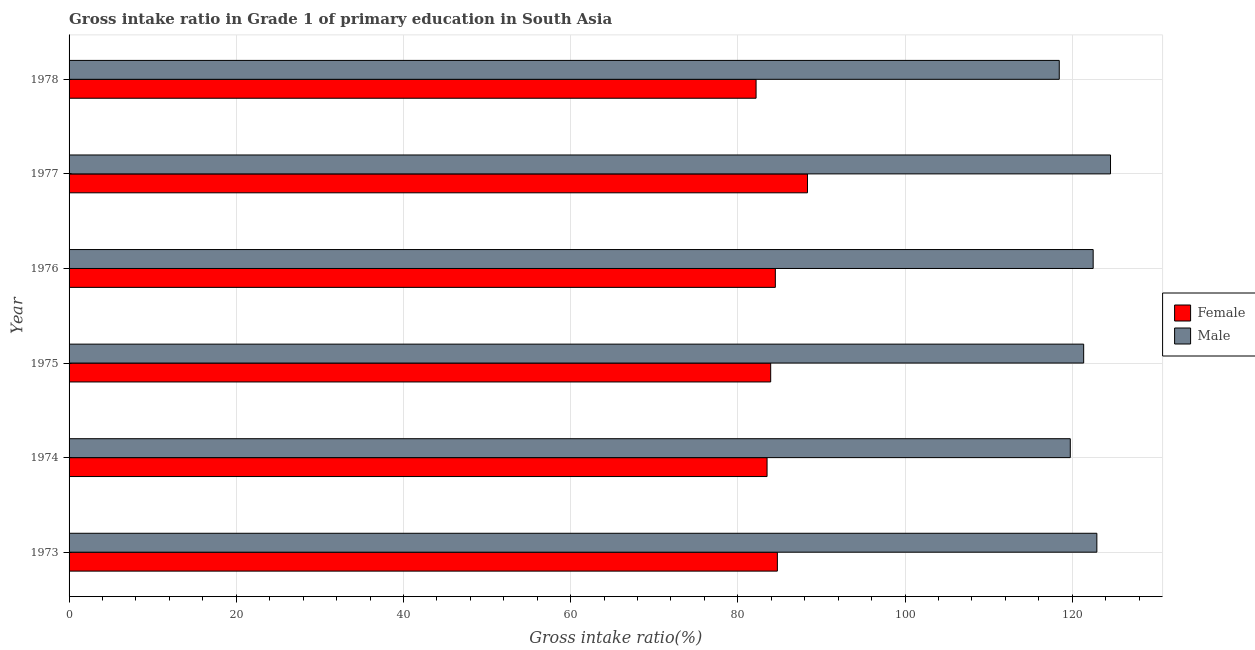How many different coloured bars are there?
Make the answer very short. 2. Are the number of bars on each tick of the Y-axis equal?
Offer a terse response. Yes. How many bars are there on the 2nd tick from the bottom?
Offer a very short reply. 2. What is the label of the 4th group of bars from the top?
Offer a very short reply. 1975. What is the gross intake ratio(female) in 1974?
Make the answer very short. 83.5. Across all years, what is the maximum gross intake ratio(male)?
Your answer should be very brief. 124.58. Across all years, what is the minimum gross intake ratio(male)?
Ensure brevity in your answer.  118.45. In which year was the gross intake ratio(male) minimum?
Ensure brevity in your answer.  1978. What is the total gross intake ratio(male) in the graph?
Keep it short and to the point. 729.63. What is the difference between the gross intake ratio(female) in 1973 and that in 1974?
Your response must be concise. 1.23. What is the difference between the gross intake ratio(female) in 1976 and the gross intake ratio(male) in 1974?
Keep it short and to the point. -35.28. What is the average gross intake ratio(male) per year?
Your answer should be compact. 121.6. In the year 1975, what is the difference between the gross intake ratio(male) and gross intake ratio(female)?
Provide a succinct answer. 37.44. What is the ratio of the gross intake ratio(female) in 1974 to that in 1977?
Your answer should be compact. 0.94. What is the difference between the highest and the second highest gross intake ratio(male)?
Make the answer very short. 1.63. What is the difference between the highest and the lowest gross intake ratio(female)?
Your answer should be compact. 6.15. In how many years, is the gross intake ratio(female) greater than the average gross intake ratio(female) taken over all years?
Give a very brief answer. 2. Is the sum of the gross intake ratio(female) in 1973 and 1977 greater than the maximum gross intake ratio(male) across all years?
Your response must be concise. Yes. How many bars are there?
Provide a succinct answer. 12. What is the difference between two consecutive major ticks on the X-axis?
Make the answer very short. 20. Are the values on the major ticks of X-axis written in scientific E-notation?
Your answer should be compact. No. Does the graph contain grids?
Offer a terse response. Yes. What is the title of the graph?
Provide a succinct answer. Gross intake ratio in Grade 1 of primary education in South Asia. Does "Revenue" appear as one of the legend labels in the graph?
Offer a terse response. No. What is the label or title of the X-axis?
Your response must be concise. Gross intake ratio(%). What is the label or title of the Y-axis?
Give a very brief answer. Year. What is the Gross intake ratio(%) of Female in 1973?
Your response must be concise. 84.73. What is the Gross intake ratio(%) in Male in 1973?
Give a very brief answer. 122.95. What is the Gross intake ratio(%) in Female in 1974?
Keep it short and to the point. 83.5. What is the Gross intake ratio(%) of Male in 1974?
Your answer should be compact. 119.77. What is the Gross intake ratio(%) in Female in 1975?
Make the answer very short. 83.93. What is the Gross intake ratio(%) in Male in 1975?
Give a very brief answer. 121.37. What is the Gross intake ratio(%) in Female in 1976?
Your response must be concise. 84.49. What is the Gross intake ratio(%) of Male in 1976?
Give a very brief answer. 122.51. What is the Gross intake ratio(%) of Female in 1977?
Keep it short and to the point. 88.33. What is the Gross intake ratio(%) in Male in 1977?
Offer a terse response. 124.58. What is the Gross intake ratio(%) in Female in 1978?
Offer a terse response. 82.18. What is the Gross intake ratio(%) of Male in 1978?
Make the answer very short. 118.45. Across all years, what is the maximum Gross intake ratio(%) of Female?
Make the answer very short. 88.33. Across all years, what is the maximum Gross intake ratio(%) in Male?
Keep it short and to the point. 124.58. Across all years, what is the minimum Gross intake ratio(%) in Female?
Provide a succinct answer. 82.18. Across all years, what is the minimum Gross intake ratio(%) of Male?
Your answer should be very brief. 118.45. What is the total Gross intake ratio(%) in Female in the graph?
Your answer should be compact. 507.16. What is the total Gross intake ratio(%) of Male in the graph?
Provide a short and direct response. 729.63. What is the difference between the Gross intake ratio(%) in Female in 1973 and that in 1974?
Give a very brief answer. 1.23. What is the difference between the Gross intake ratio(%) of Male in 1973 and that in 1974?
Offer a very short reply. 3.18. What is the difference between the Gross intake ratio(%) in Female in 1973 and that in 1975?
Provide a succinct answer. 0.8. What is the difference between the Gross intake ratio(%) of Male in 1973 and that in 1975?
Offer a terse response. 1.58. What is the difference between the Gross intake ratio(%) in Female in 1973 and that in 1976?
Offer a terse response. 0.24. What is the difference between the Gross intake ratio(%) in Male in 1973 and that in 1976?
Your answer should be very brief. 0.44. What is the difference between the Gross intake ratio(%) in Female in 1973 and that in 1977?
Offer a terse response. -3.6. What is the difference between the Gross intake ratio(%) in Male in 1973 and that in 1977?
Offer a terse response. -1.63. What is the difference between the Gross intake ratio(%) of Female in 1973 and that in 1978?
Your answer should be very brief. 2.55. What is the difference between the Gross intake ratio(%) in Male in 1973 and that in 1978?
Ensure brevity in your answer.  4.5. What is the difference between the Gross intake ratio(%) of Female in 1974 and that in 1975?
Keep it short and to the point. -0.43. What is the difference between the Gross intake ratio(%) of Male in 1974 and that in 1975?
Your answer should be very brief. -1.6. What is the difference between the Gross intake ratio(%) of Female in 1974 and that in 1976?
Ensure brevity in your answer.  -0.99. What is the difference between the Gross intake ratio(%) of Male in 1974 and that in 1976?
Offer a very short reply. -2.73. What is the difference between the Gross intake ratio(%) of Female in 1974 and that in 1977?
Provide a succinct answer. -4.84. What is the difference between the Gross intake ratio(%) in Male in 1974 and that in 1977?
Keep it short and to the point. -4.81. What is the difference between the Gross intake ratio(%) of Female in 1974 and that in 1978?
Keep it short and to the point. 1.31. What is the difference between the Gross intake ratio(%) of Male in 1974 and that in 1978?
Your answer should be compact. 1.32. What is the difference between the Gross intake ratio(%) of Female in 1975 and that in 1976?
Offer a terse response. -0.56. What is the difference between the Gross intake ratio(%) of Male in 1975 and that in 1976?
Keep it short and to the point. -1.14. What is the difference between the Gross intake ratio(%) of Female in 1975 and that in 1977?
Your answer should be very brief. -4.4. What is the difference between the Gross intake ratio(%) of Male in 1975 and that in 1977?
Make the answer very short. -3.21. What is the difference between the Gross intake ratio(%) of Female in 1975 and that in 1978?
Your response must be concise. 1.75. What is the difference between the Gross intake ratio(%) of Male in 1975 and that in 1978?
Make the answer very short. 2.92. What is the difference between the Gross intake ratio(%) of Female in 1976 and that in 1977?
Your answer should be very brief. -3.84. What is the difference between the Gross intake ratio(%) of Male in 1976 and that in 1977?
Keep it short and to the point. -2.08. What is the difference between the Gross intake ratio(%) in Female in 1976 and that in 1978?
Your answer should be very brief. 2.31. What is the difference between the Gross intake ratio(%) of Male in 1976 and that in 1978?
Make the answer very short. 4.06. What is the difference between the Gross intake ratio(%) in Female in 1977 and that in 1978?
Ensure brevity in your answer.  6.15. What is the difference between the Gross intake ratio(%) in Male in 1977 and that in 1978?
Ensure brevity in your answer.  6.13. What is the difference between the Gross intake ratio(%) of Female in 1973 and the Gross intake ratio(%) of Male in 1974?
Provide a succinct answer. -35.04. What is the difference between the Gross intake ratio(%) of Female in 1973 and the Gross intake ratio(%) of Male in 1975?
Your answer should be compact. -36.64. What is the difference between the Gross intake ratio(%) of Female in 1973 and the Gross intake ratio(%) of Male in 1976?
Your answer should be compact. -37.78. What is the difference between the Gross intake ratio(%) of Female in 1973 and the Gross intake ratio(%) of Male in 1977?
Keep it short and to the point. -39.85. What is the difference between the Gross intake ratio(%) of Female in 1973 and the Gross intake ratio(%) of Male in 1978?
Your response must be concise. -33.72. What is the difference between the Gross intake ratio(%) of Female in 1974 and the Gross intake ratio(%) of Male in 1975?
Your answer should be very brief. -37.87. What is the difference between the Gross intake ratio(%) of Female in 1974 and the Gross intake ratio(%) of Male in 1976?
Give a very brief answer. -39.01. What is the difference between the Gross intake ratio(%) in Female in 1974 and the Gross intake ratio(%) in Male in 1977?
Provide a short and direct response. -41.09. What is the difference between the Gross intake ratio(%) in Female in 1974 and the Gross intake ratio(%) in Male in 1978?
Offer a terse response. -34.95. What is the difference between the Gross intake ratio(%) of Female in 1975 and the Gross intake ratio(%) of Male in 1976?
Provide a short and direct response. -38.58. What is the difference between the Gross intake ratio(%) in Female in 1975 and the Gross intake ratio(%) in Male in 1977?
Ensure brevity in your answer.  -40.65. What is the difference between the Gross intake ratio(%) of Female in 1975 and the Gross intake ratio(%) of Male in 1978?
Your response must be concise. -34.52. What is the difference between the Gross intake ratio(%) in Female in 1976 and the Gross intake ratio(%) in Male in 1977?
Offer a very short reply. -40.09. What is the difference between the Gross intake ratio(%) in Female in 1976 and the Gross intake ratio(%) in Male in 1978?
Your response must be concise. -33.96. What is the difference between the Gross intake ratio(%) of Female in 1977 and the Gross intake ratio(%) of Male in 1978?
Give a very brief answer. -30.12. What is the average Gross intake ratio(%) in Female per year?
Keep it short and to the point. 84.53. What is the average Gross intake ratio(%) in Male per year?
Make the answer very short. 121.6. In the year 1973, what is the difference between the Gross intake ratio(%) of Female and Gross intake ratio(%) of Male?
Ensure brevity in your answer.  -38.22. In the year 1974, what is the difference between the Gross intake ratio(%) in Female and Gross intake ratio(%) in Male?
Keep it short and to the point. -36.27. In the year 1975, what is the difference between the Gross intake ratio(%) in Female and Gross intake ratio(%) in Male?
Ensure brevity in your answer.  -37.44. In the year 1976, what is the difference between the Gross intake ratio(%) of Female and Gross intake ratio(%) of Male?
Your response must be concise. -38.02. In the year 1977, what is the difference between the Gross intake ratio(%) in Female and Gross intake ratio(%) in Male?
Your response must be concise. -36.25. In the year 1978, what is the difference between the Gross intake ratio(%) in Female and Gross intake ratio(%) in Male?
Offer a very short reply. -36.27. What is the ratio of the Gross intake ratio(%) of Female in 1973 to that in 1974?
Offer a terse response. 1.01. What is the ratio of the Gross intake ratio(%) of Male in 1973 to that in 1974?
Your answer should be compact. 1.03. What is the ratio of the Gross intake ratio(%) of Female in 1973 to that in 1975?
Offer a very short reply. 1.01. What is the ratio of the Gross intake ratio(%) of Male in 1973 to that in 1975?
Make the answer very short. 1.01. What is the ratio of the Gross intake ratio(%) of Male in 1973 to that in 1976?
Keep it short and to the point. 1. What is the ratio of the Gross intake ratio(%) of Female in 1973 to that in 1977?
Give a very brief answer. 0.96. What is the ratio of the Gross intake ratio(%) of Male in 1973 to that in 1977?
Your answer should be very brief. 0.99. What is the ratio of the Gross intake ratio(%) of Female in 1973 to that in 1978?
Keep it short and to the point. 1.03. What is the ratio of the Gross intake ratio(%) of Male in 1973 to that in 1978?
Make the answer very short. 1.04. What is the ratio of the Gross intake ratio(%) in Female in 1974 to that in 1975?
Your answer should be compact. 0.99. What is the ratio of the Gross intake ratio(%) of Female in 1974 to that in 1976?
Provide a succinct answer. 0.99. What is the ratio of the Gross intake ratio(%) of Male in 1974 to that in 1976?
Make the answer very short. 0.98. What is the ratio of the Gross intake ratio(%) of Female in 1974 to that in 1977?
Your response must be concise. 0.95. What is the ratio of the Gross intake ratio(%) in Male in 1974 to that in 1977?
Your response must be concise. 0.96. What is the ratio of the Gross intake ratio(%) in Female in 1974 to that in 1978?
Provide a short and direct response. 1.02. What is the ratio of the Gross intake ratio(%) of Male in 1974 to that in 1978?
Offer a very short reply. 1.01. What is the ratio of the Gross intake ratio(%) of Female in 1975 to that in 1977?
Offer a terse response. 0.95. What is the ratio of the Gross intake ratio(%) of Male in 1975 to that in 1977?
Your answer should be very brief. 0.97. What is the ratio of the Gross intake ratio(%) of Female in 1975 to that in 1978?
Give a very brief answer. 1.02. What is the ratio of the Gross intake ratio(%) of Male in 1975 to that in 1978?
Give a very brief answer. 1.02. What is the ratio of the Gross intake ratio(%) of Female in 1976 to that in 1977?
Provide a short and direct response. 0.96. What is the ratio of the Gross intake ratio(%) of Male in 1976 to that in 1977?
Keep it short and to the point. 0.98. What is the ratio of the Gross intake ratio(%) in Female in 1976 to that in 1978?
Offer a terse response. 1.03. What is the ratio of the Gross intake ratio(%) in Male in 1976 to that in 1978?
Make the answer very short. 1.03. What is the ratio of the Gross intake ratio(%) of Female in 1977 to that in 1978?
Offer a terse response. 1.07. What is the ratio of the Gross intake ratio(%) in Male in 1977 to that in 1978?
Offer a very short reply. 1.05. What is the difference between the highest and the second highest Gross intake ratio(%) in Female?
Provide a short and direct response. 3.6. What is the difference between the highest and the second highest Gross intake ratio(%) of Male?
Your answer should be very brief. 1.63. What is the difference between the highest and the lowest Gross intake ratio(%) of Female?
Offer a very short reply. 6.15. What is the difference between the highest and the lowest Gross intake ratio(%) in Male?
Offer a terse response. 6.13. 